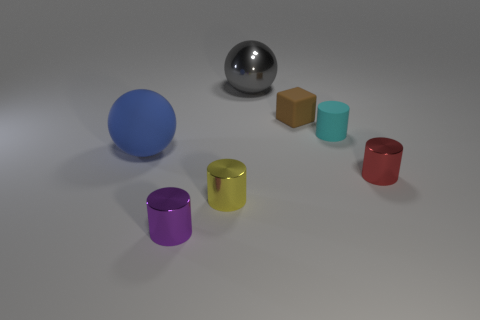Add 1 tiny brown rubber cubes. How many objects exist? 8 Subtract all cylinders. How many objects are left? 3 Subtract all large balls. Subtract all big yellow metallic balls. How many objects are left? 5 Add 3 yellow things. How many yellow things are left? 4 Add 4 tiny brown metallic objects. How many tiny brown metallic objects exist? 4 Subtract 0 brown cylinders. How many objects are left? 7 